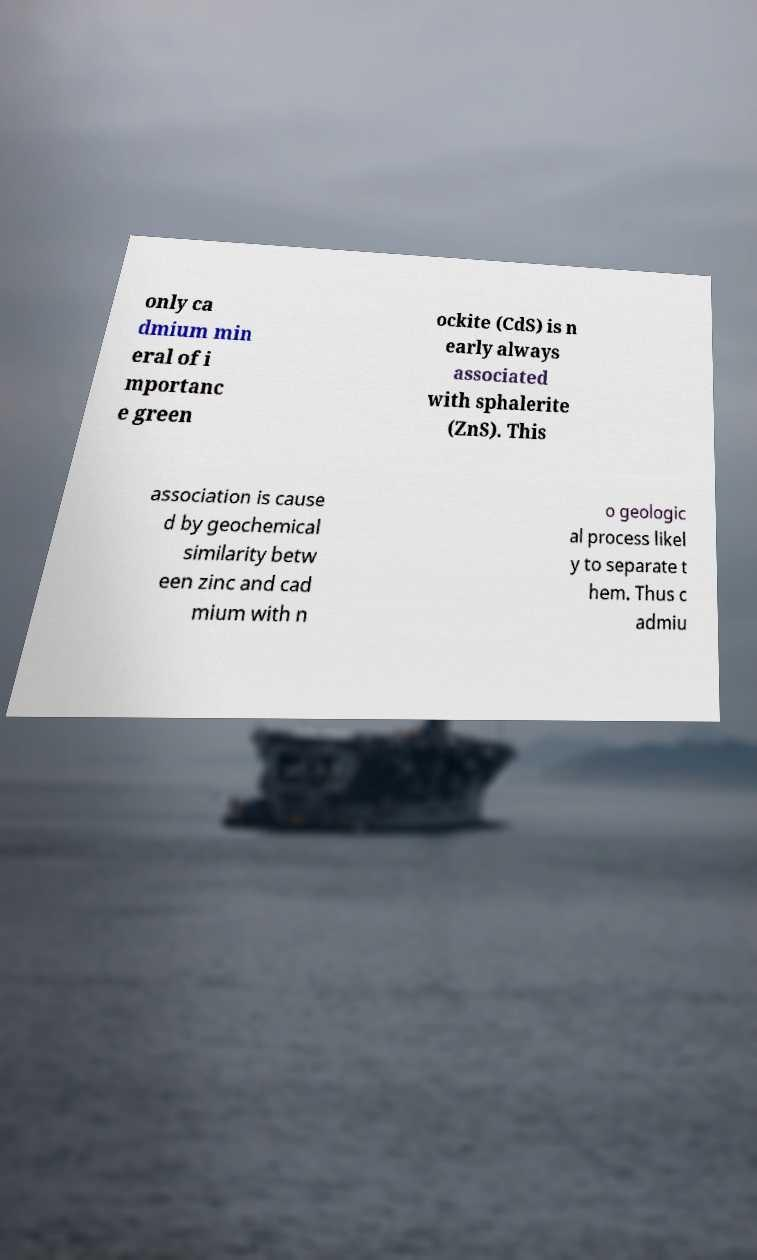What messages or text are displayed in this image? I need them in a readable, typed format. only ca dmium min eral of i mportanc e green ockite (CdS) is n early always associated with sphalerite (ZnS). This association is cause d by geochemical similarity betw een zinc and cad mium with n o geologic al process likel y to separate t hem. Thus c admiu 